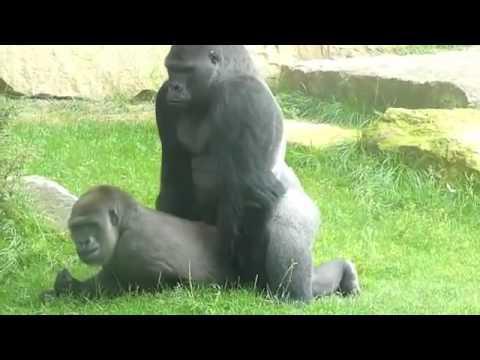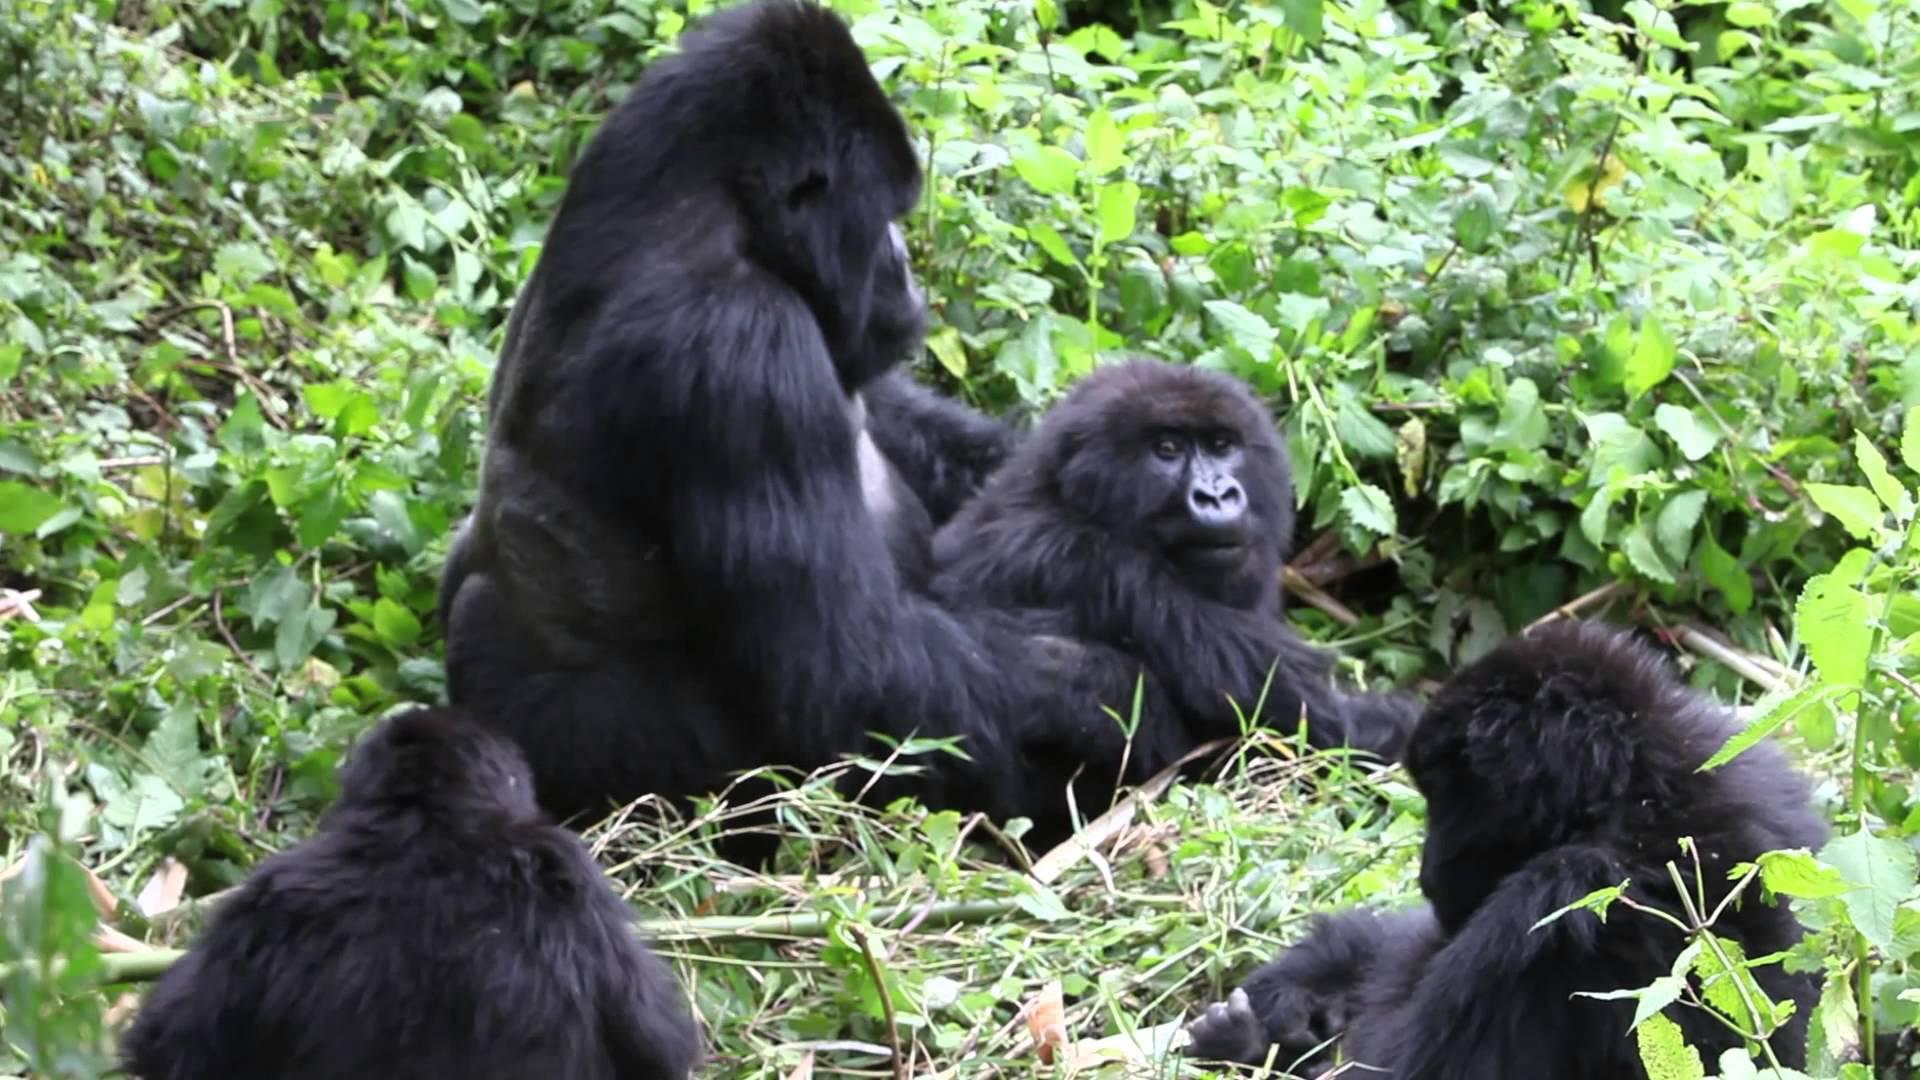The first image is the image on the left, the second image is the image on the right. For the images shown, is this caption "There are at most two adult gorillas." true? Answer yes or no. No. The first image is the image on the left, the second image is the image on the right. Evaluate the accuracy of this statement regarding the images: "In one of the images there is one animal all by itself.". Is it true? Answer yes or no. No. 